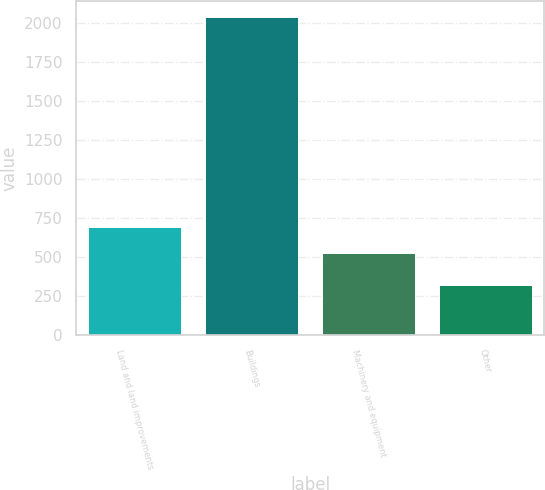<chart> <loc_0><loc_0><loc_500><loc_500><bar_chart><fcel>Land and land improvements<fcel>Buildings<fcel>Machinery and equipment<fcel>Other<nl><fcel>697<fcel>2040<fcel>525<fcel>320<nl></chart> 